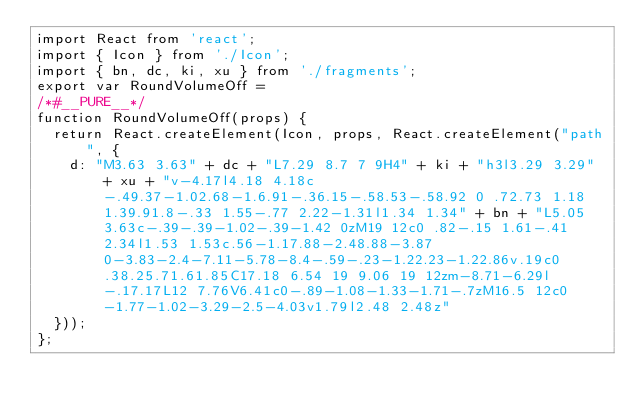Convert code to text. <code><loc_0><loc_0><loc_500><loc_500><_JavaScript_>import React from 'react';
import { Icon } from './Icon';
import { bn, dc, ki, xu } from './fragments';
export var RoundVolumeOff =
/*#__PURE__*/
function RoundVolumeOff(props) {
  return React.createElement(Icon, props, React.createElement("path", {
    d: "M3.63 3.63" + dc + "L7.29 8.7 7 9H4" + ki + "h3l3.29 3.29" + xu + "v-4.17l4.18 4.18c-.49.37-1.02.68-1.6.91-.36.15-.58.53-.58.92 0 .72.73 1.18 1.39.91.8-.33 1.55-.77 2.22-1.31l1.34 1.34" + bn + "L5.05 3.63c-.39-.39-1.02-.39-1.42 0zM19 12c0 .82-.15 1.61-.41 2.34l1.53 1.53c.56-1.17.88-2.48.88-3.87 0-3.83-2.4-7.11-5.78-8.4-.59-.23-1.22.23-1.22.86v.19c0 .38.25.71.61.85C17.18 6.54 19 9.06 19 12zm-8.71-6.29l-.17.17L12 7.76V6.41c0-.89-1.08-1.33-1.71-.7zM16.5 12c0-1.77-1.02-3.29-2.5-4.03v1.79l2.48 2.48z"
  }));
};</code> 